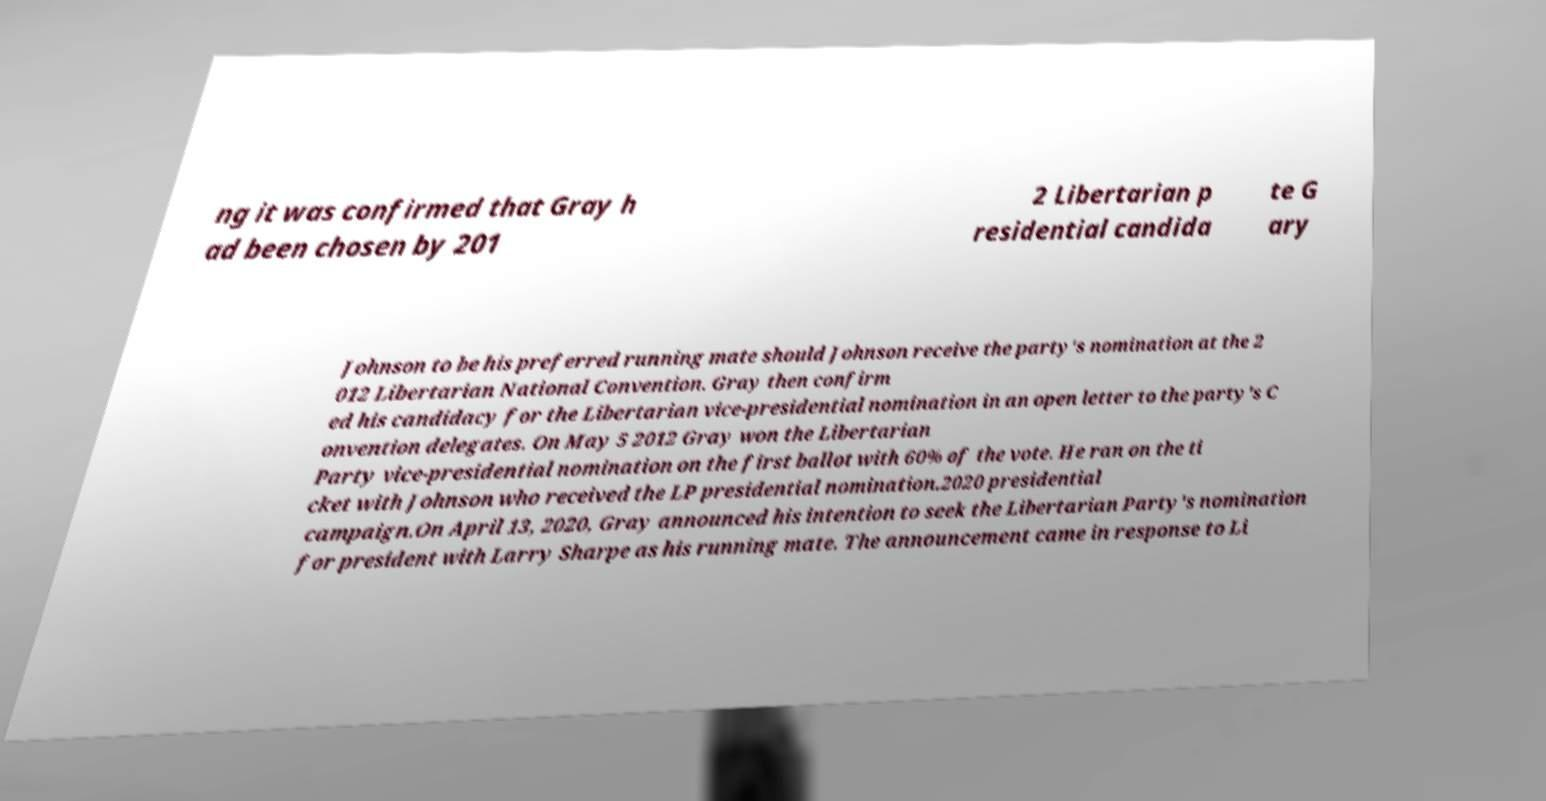Please identify and transcribe the text found in this image. ng it was confirmed that Gray h ad been chosen by 201 2 Libertarian p residential candida te G ary Johnson to be his preferred running mate should Johnson receive the party's nomination at the 2 012 Libertarian National Convention. Gray then confirm ed his candidacy for the Libertarian vice-presidential nomination in an open letter to the party's C onvention delegates. On May 5 2012 Gray won the Libertarian Party vice-presidential nomination on the first ballot with 60% of the vote. He ran on the ti cket with Johnson who received the LP presidential nomination.2020 presidential campaign.On April 13, 2020, Gray announced his intention to seek the Libertarian Party's nomination for president with Larry Sharpe as his running mate. The announcement came in response to Li 